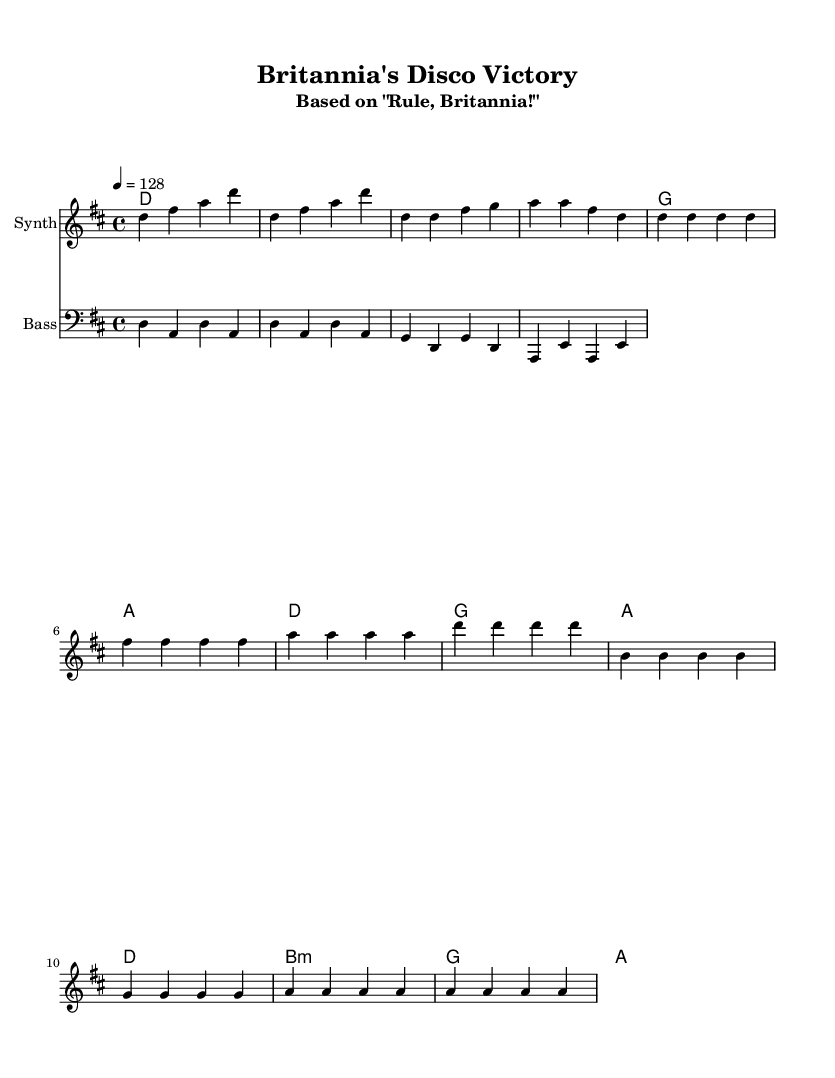What is the key signature of this music? The key signature is indicated as "d major," which has two sharps (F# and C#).
Answer: d major What is the time signature of this music? The time signature is shown as "4/4," meaning there are four beats in a measure and the quarter note gets one beat.
Answer: 4/4 What is the tempo marking for this piece? The tempo marking indicates a speed of "128 beats per minute," which is relatively fast and suitable for dance music.
Answer: 128 How many measures are in the chorus section? By analyzing the chorus section, there are a total of 4 measures indicated, as each statement consists of a repeated 4-note pattern.
Answer: 4 Which instrument plays the melody? The melody is specifically assigned to a staff labeled "Synth," indicating that this is the instrument meant to play the main melodic line.
Answer: Synth What chords are used in the bridge section? The bridge section consists of three chords, which can be identified as B minor, G major, and A major, denoting the harmonic progression.
Answer: B minor, G, A What is the rhythmic pattern of the bass line in the introduction? The bass line in the introduction contains a consistent rhythmic pattern of quarter notes followed by syncopation in the notes played, establishing a groove.
Answer: D, A, D, A 